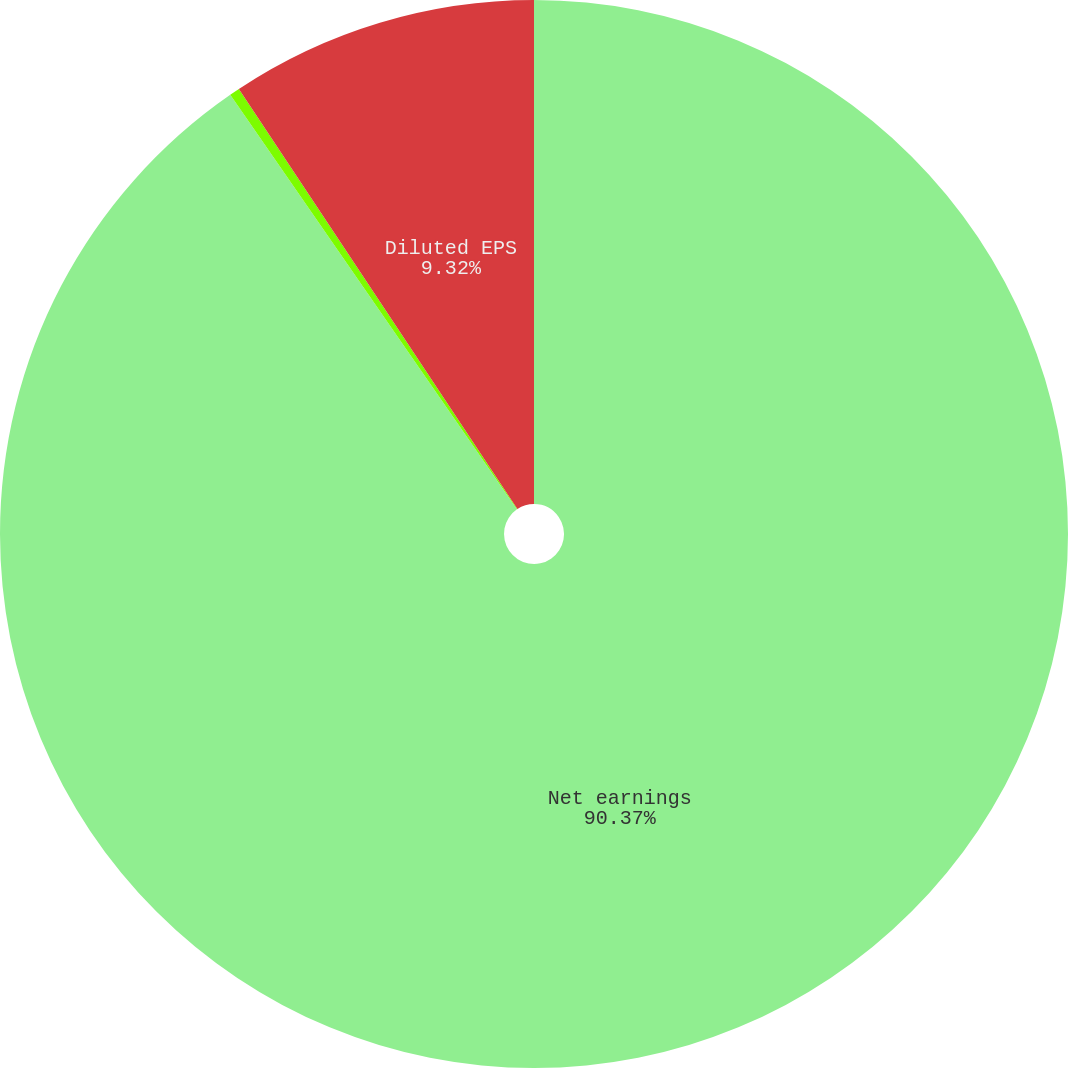Convert chart. <chart><loc_0><loc_0><loc_500><loc_500><pie_chart><fcel>Net earnings<fcel>Basic EPS<fcel>Diluted EPS<nl><fcel>90.37%<fcel>0.31%<fcel>9.32%<nl></chart> 